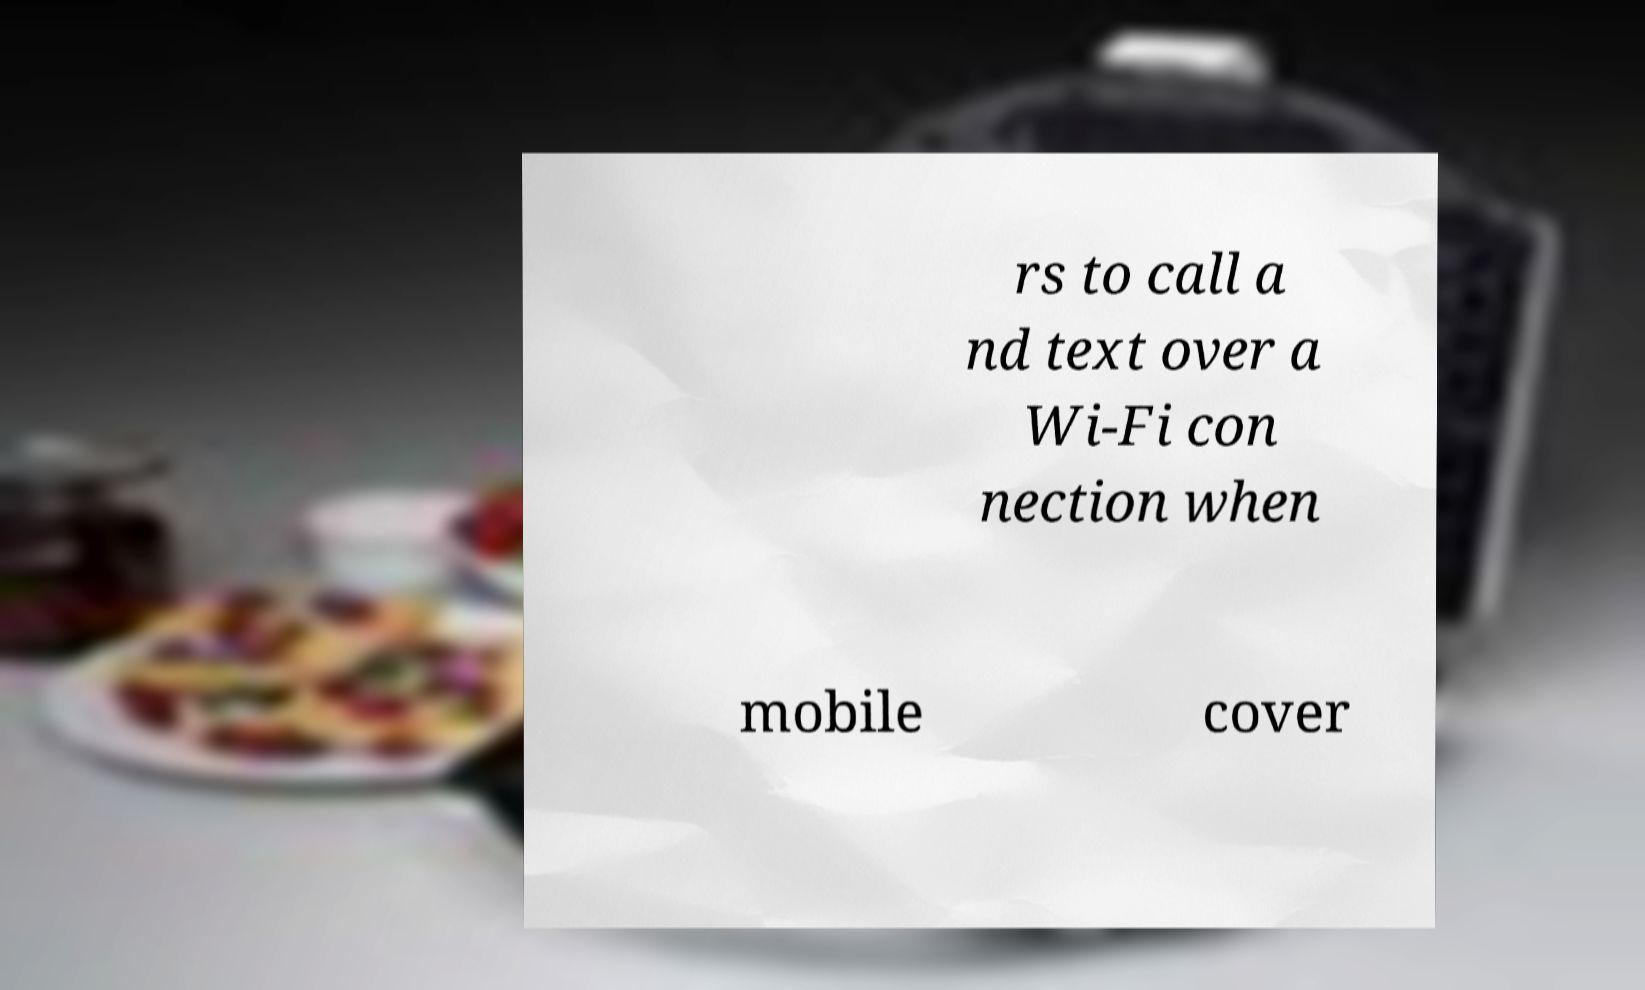Can you read and provide the text displayed in the image?This photo seems to have some interesting text. Can you extract and type it out for me? rs to call a nd text over a Wi-Fi con nection when mobile cover 